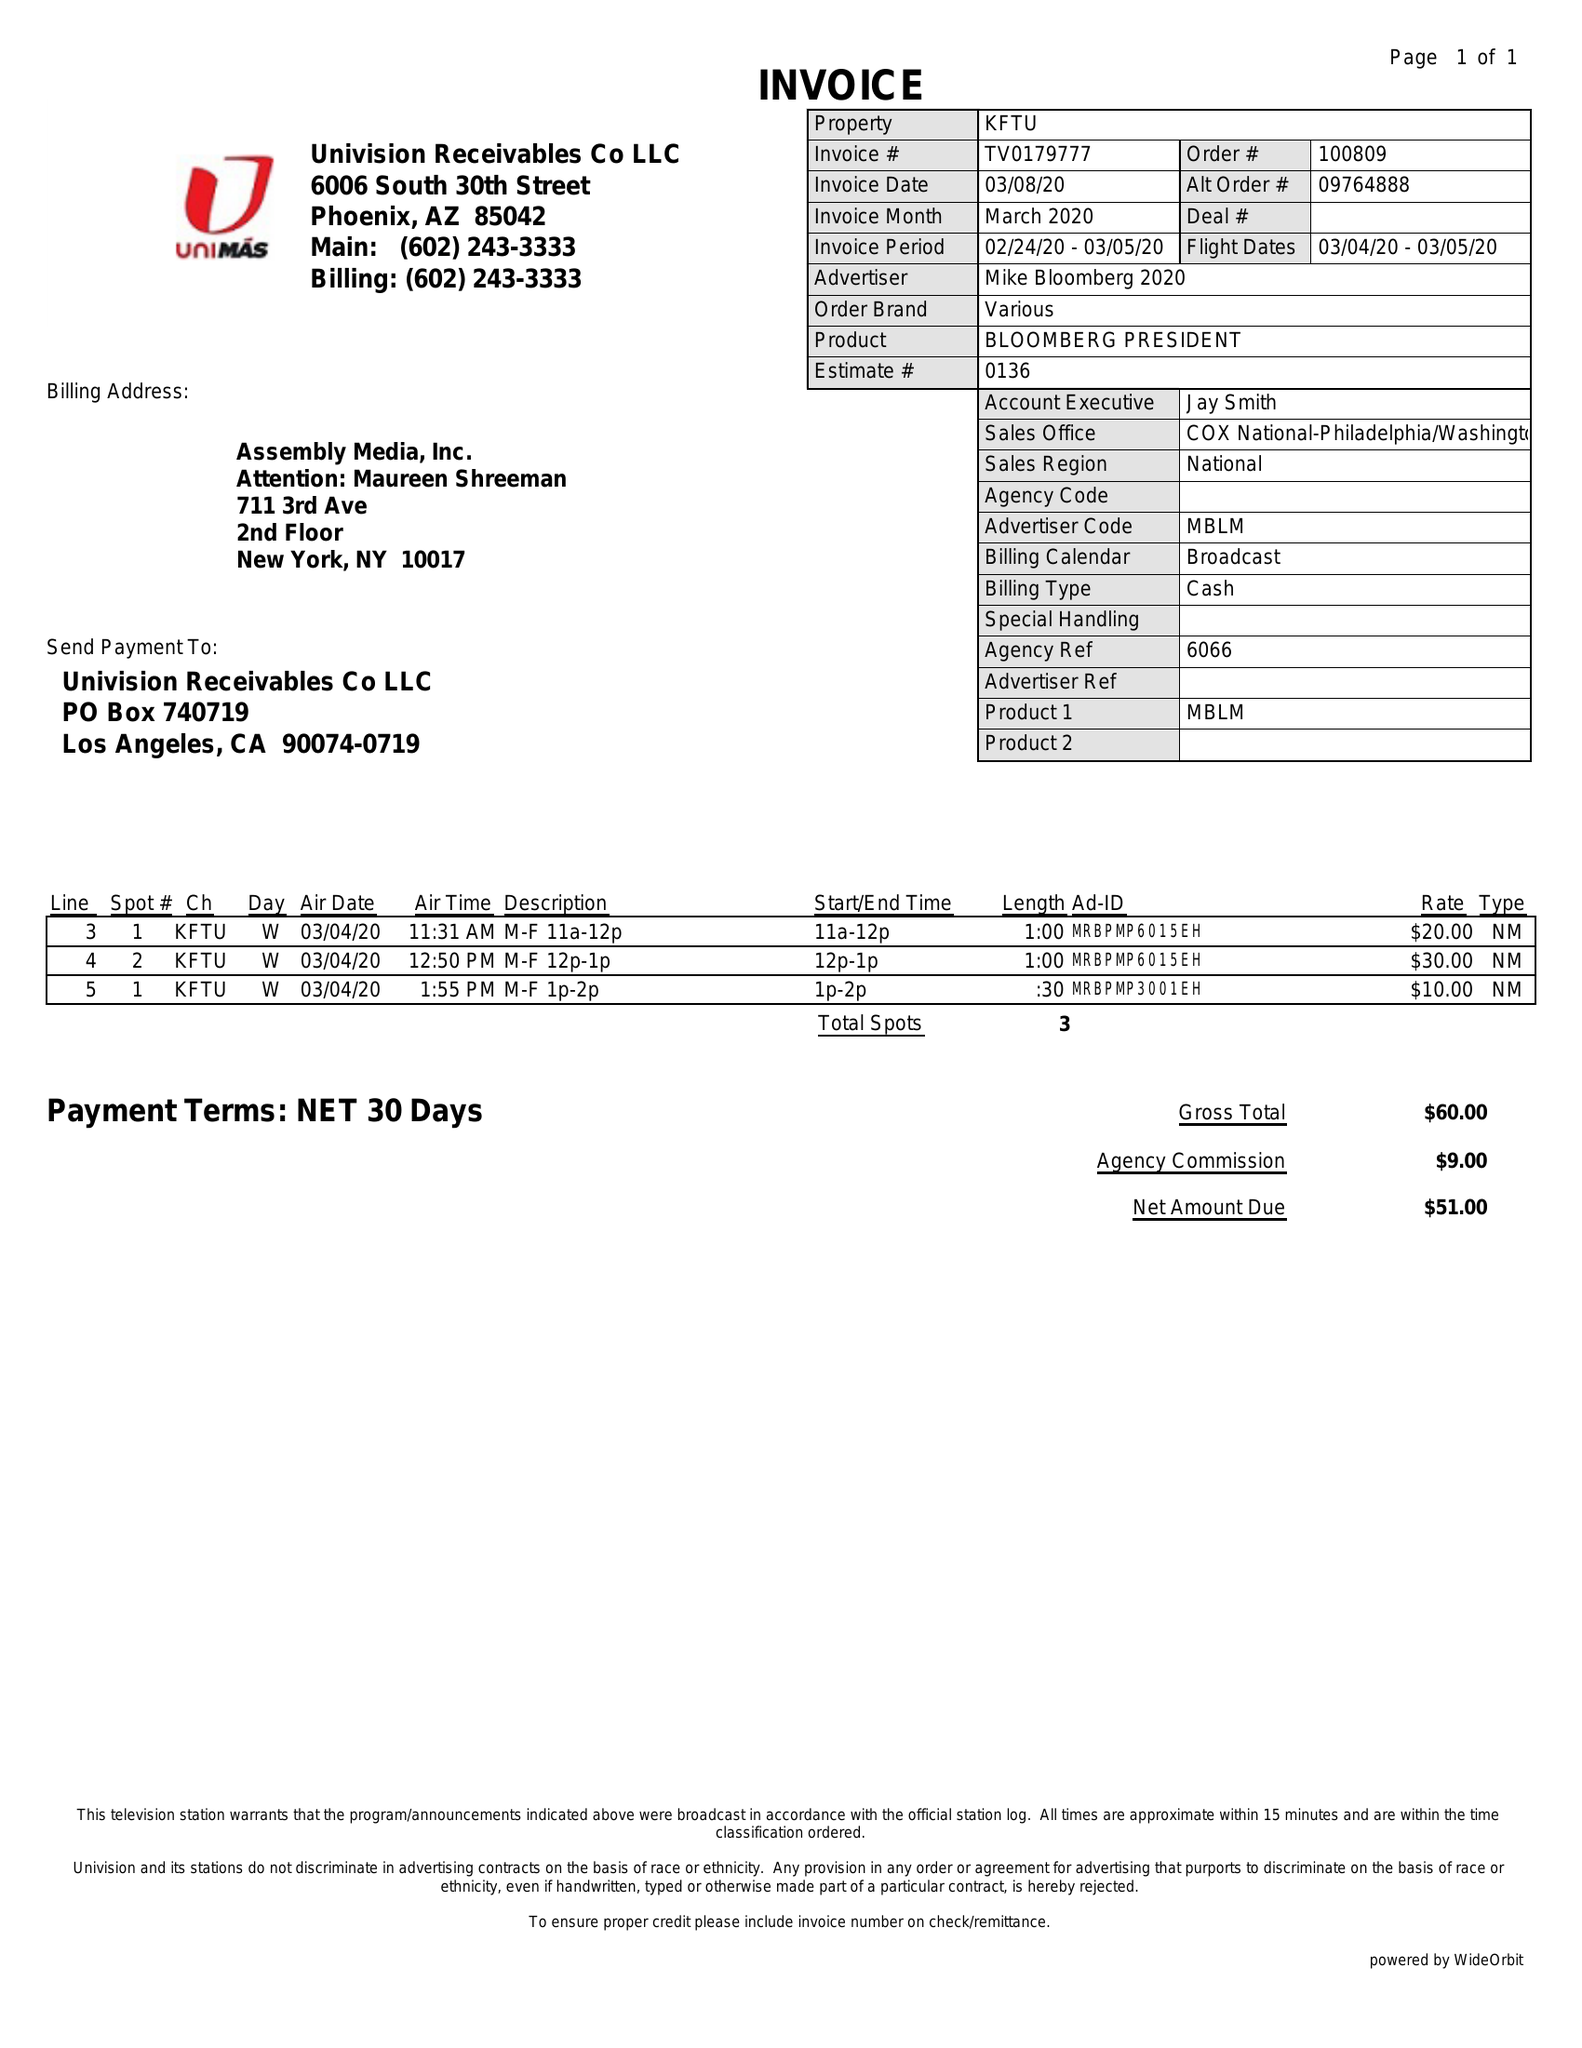What is the value for the gross_amount?
Answer the question using a single word or phrase. 60.00 